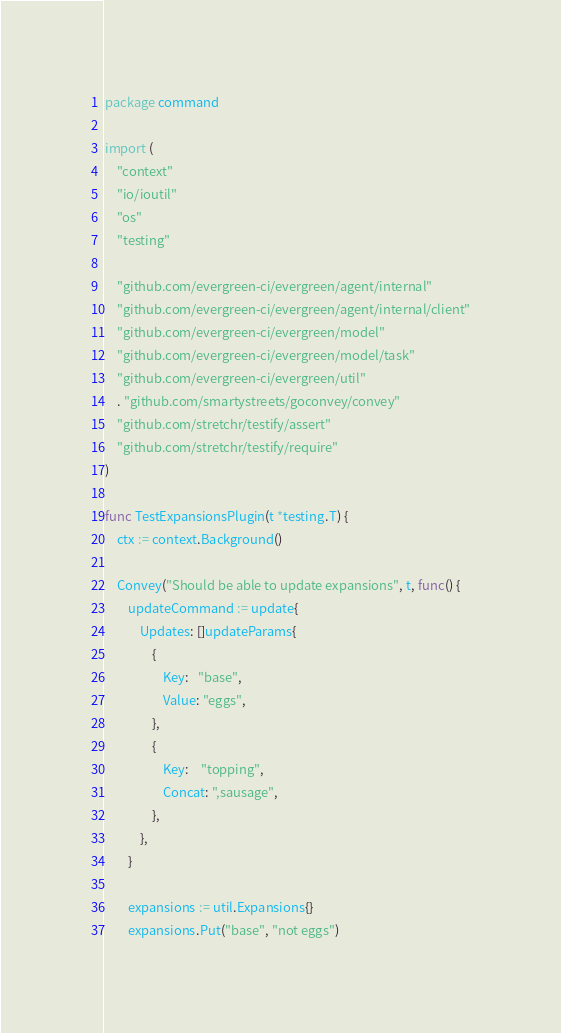Convert code to text. <code><loc_0><loc_0><loc_500><loc_500><_Go_>package command

import (
	"context"
	"io/ioutil"
	"os"
	"testing"

	"github.com/evergreen-ci/evergreen/agent/internal"
	"github.com/evergreen-ci/evergreen/agent/internal/client"
	"github.com/evergreen-ci/evergreen/model"
	"github.com/evergreen-ci/evergreen/model/task"
	"github.com/evergreen-ci/evergreen/util"
	. "github.com/smartystreets/goconvey/convey"
	"github.com/stretchr/testify/assert"
	"github.com/stretchr/testify/require"
)

func TestExpansionsPlugin(t *testing.T) {
	ctx := context.Background()

	Convey("Should be able to update expansions", t, func() {
		updateCommand := update{
			Updates: []updateParams{
				{
					Key:   "base",
					Value: "eggs",
				},
				{
					Key:    "topping",
					Concat: ",sausage",
				},
			},
		}

		expansions := util.Expansions{}
		expansions.Put("base", "not eggs")</code> 